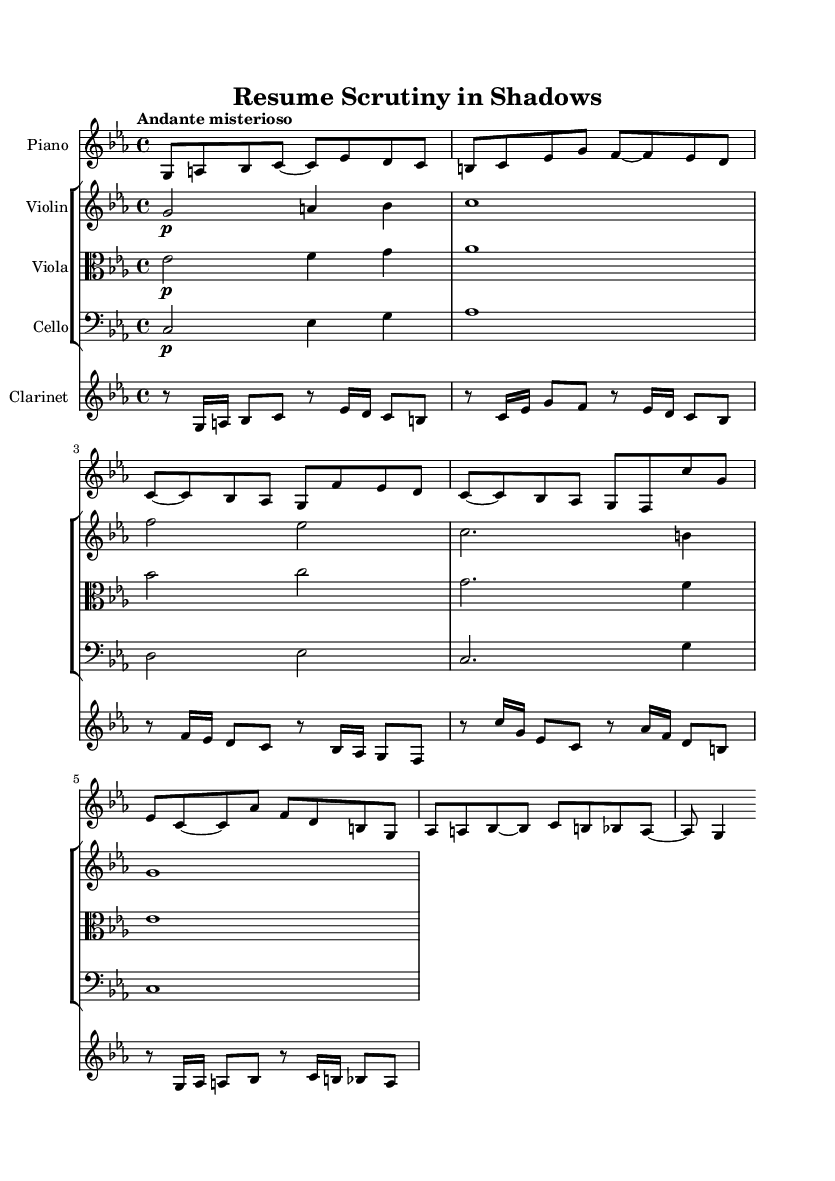What is the key signature of this music? The key signature is C minor, indicated by three flats in the key signature area at the beginning of the staff.
Answer: C minor What is the time signature of the piece? The time signature is 4/4, which is indicated at the beginning of the score and informs the performer of the number of beats per measure and the value of the beats.
Answer: 4/4 What tempo marking is given for this music? The tempo marking is "Andante misterioso," which instructs the performer to play at a moderate pace with an air of mystery. This can be found at the beginning of the score near the time signature.
Answer: Andante misterioso In which clef is the piano part written? The piano part is written in the treble clef, as indicated at the start of the piano staff. This clef is commonly used for higher pitches, typically used for right-hand notes on the piano.
Answer: Treble clef How many measures are in the piano part? The piano part contains ten measures, which can be counted by noting the vertical lines (bar lines) separating each measure in the staff.
Answer: Ten measures Which instrument has the longest note value in the first system? The violin has the longest note value in the first system, a whole note that lasts for four beats, while the other instruments have shorter note values in their respective measures.
Answer: Violin What dynamic marking is indicated for the clarinet part? The clarinet part has several dynamic markings, the first being indicated as a piano (p) at the beginning, meaning to play softly. It is an essential part of the performance dynamics outlined in the music.
Answer: Piano 